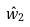Convert formula to latex. <formula><loc_0><loc_0><loc_500><loc_500>\hat { w } _ { 2 }</formula> 